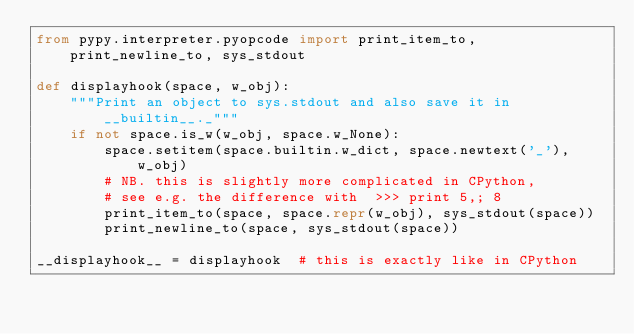<code> <loc_0><loc_0><loc_500><loc_500><_Python_>from pypy.interpreter.pyopcode import print_item_to, print_newline_to, sys_stdout 

def displayhook(space, w_obj):
    """Print an object to sys.stdout and also save it in __builtin__._"""
    if not space.is_w(w_obj, space.w_None): 
        space.setitem(space.builtin.w_dict, space.newtext('_'), w_obj)
        # NB. this is slightly more complicated in CPython,
        # see e.g. the difference with  >>> print 5,; 8
        print_item_to(space, space.repr(w_obj), sys_stdout(space))
        print_newline_to(space, sys_stdout(space))

__displayhook__ = displayhook  # this is exactly like in CPython

</code> 